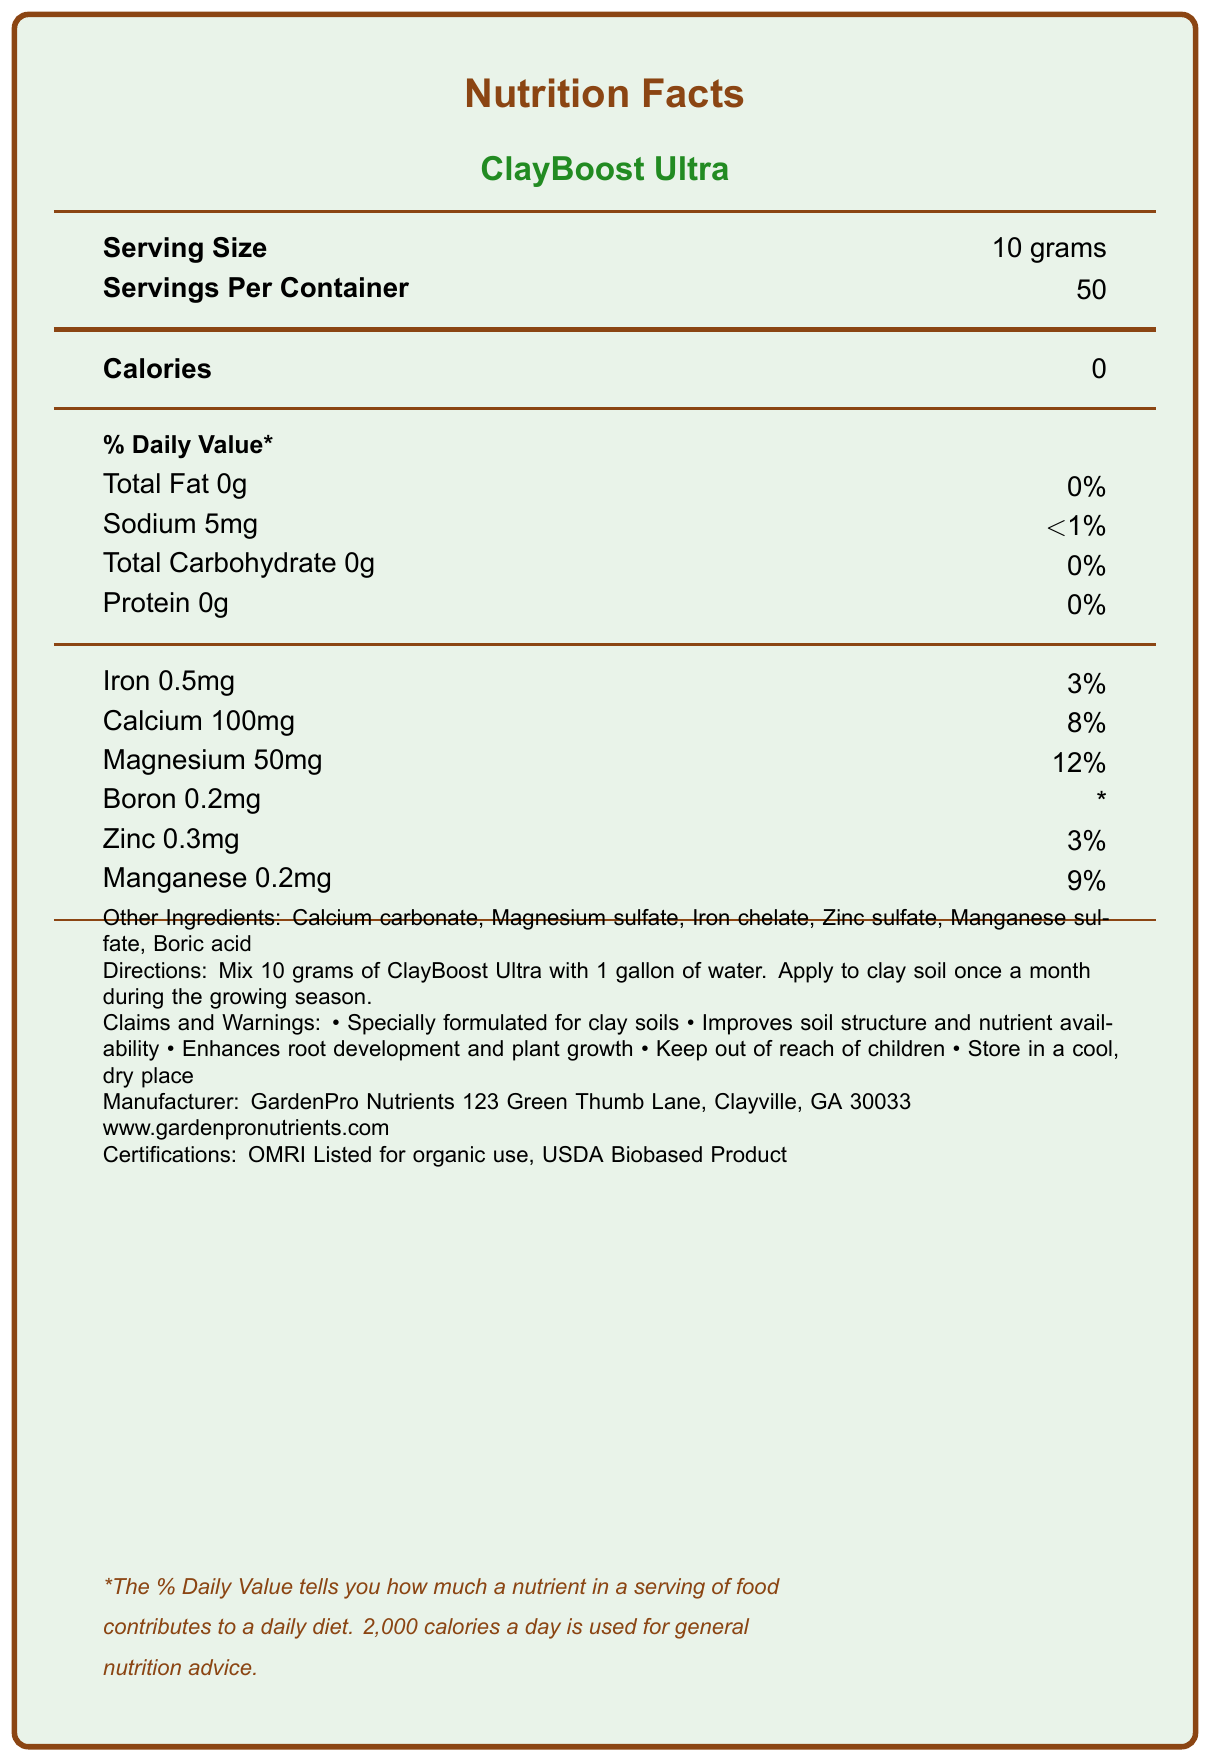What is the serving size of ClayBoost Ultra? The serving size is directly stated under the 'Serving Size' header in the document as 10 grams.
Answer: 10 grams How many servings are there in each container of ClayBoost Ultra? The number of servings per container is listed next to the 'Servings Per Container' header as 50.
Answer: 50 How many calories are in one serving of ClayBoost Ultra? The calorie content per serving is shown under the 'Calories' header and reads 0.
Answer: 0 What is the main purpose of ClayBoost Ultra according to the claims section? The claims section includes statements that highlight the product’s purpose, including improving soil structure and nutrient availability.
Answer: Improves soil structure and nutrient availability What company manufactures ClayBoost Ultra? The manufacturer's information is listed at the end of the document, stating "Manufacturer: GardenPro Nutrients."
Answer: GardenPro Nutrients What percent of the daily value does 50mg of Magnesium provide? It is mentioned under the 'Magnesium' section as providing 12% of the daily value.
Answer: 12% Why should ClayBoost Ultra be kept out of reach of children? A. It can cause allergies in children B. It is essential for its effectiveness C. It is a safety precaution D. It may lose its effectiveness if exposed to children The document lists "Keep out of reach of children" as a warning, which is a common safety precaution.
Answer: C Which ingredient is NOT listed under "Other Ingredients"? 1. Iron chelate 2. Zinc sulfate 3. Nitrogen 4. Boric acid The document lists all other ingredients except Nitrogen under the "Other Ingredients" section.
Answer: 3 Is the product certified for organic use? The certifications section states that ClayBoost Ultra is OMRI Listed for organic use.
Answer: Yes Does ClayBoost Ultra contain any protein? The nutrient section mentions that the amount of protein is 0g per serving.
Answer: No Summarize the main idea of the document. The document outlines the nutritional facts, usage instructions, benefits, warnings, certifications, and ingredient list for a specialized plant food designed for clay soils.
Answer: ClayBoost Ultra is a micronutrient-rich plant food designed for clay soils. It contains several essential micronutrients such as Iron, Calcium, Magnesium, Boron, Zinc, and Manganese. The product offers specific benefits like improved soil structure, nutrient availability, and better root development. It is manufactured by GardenPro Nutrients and has certifications for organic use. The document also includes usage directions, warnings, and a list of ingredients. How is the daily value percentage of Sodium represented in the document? The document lists Sodium's daily value as less than 1%, represented as "<1%".
Answer: <1% What precautions are mentioned in the claims and warnings section? The document mentions these two specific precautions under the claims and warnings section.
Answer: Keep out of reach of children; Store in a cool, dry place What are the directions for using ClayBoost Ultra? The directions section provides these specific instructions for usage.
Answer: Mix 10 grams of ClayBoost Ultra with 1 gallon of water. Apply to clay soil once a month during the growing season. What type of environment should ClayBoost Ultra be stored in? The claims and warnings section advises storing the product in a cool, dry place.
Answer: A cool, dry place What is the daily value percentage of Iron provided in one serving of ClayBoost Ultra? The document lists Iron at 0.5mg, 3% daily value, per serving.
Answer: 3% What is the website for GardenPro Nutrients? The manufacturer information section lists the website as www.gardenpronutrients.com.
Answer: www.gardenpronutrients.com Can the daily value of Boron be determined from the document? The document marks the daily value of Boron with an asterisk (*), indicating it's not provided.
Answer: No What are the primary micronutrients listed in ClayBoost Ultra? The micronutrients section lists these primary micronutrients with their respective amounts and daily values.
Answer: Iron, Calcium, Magnesium, Boron, Zinc, Manganese 